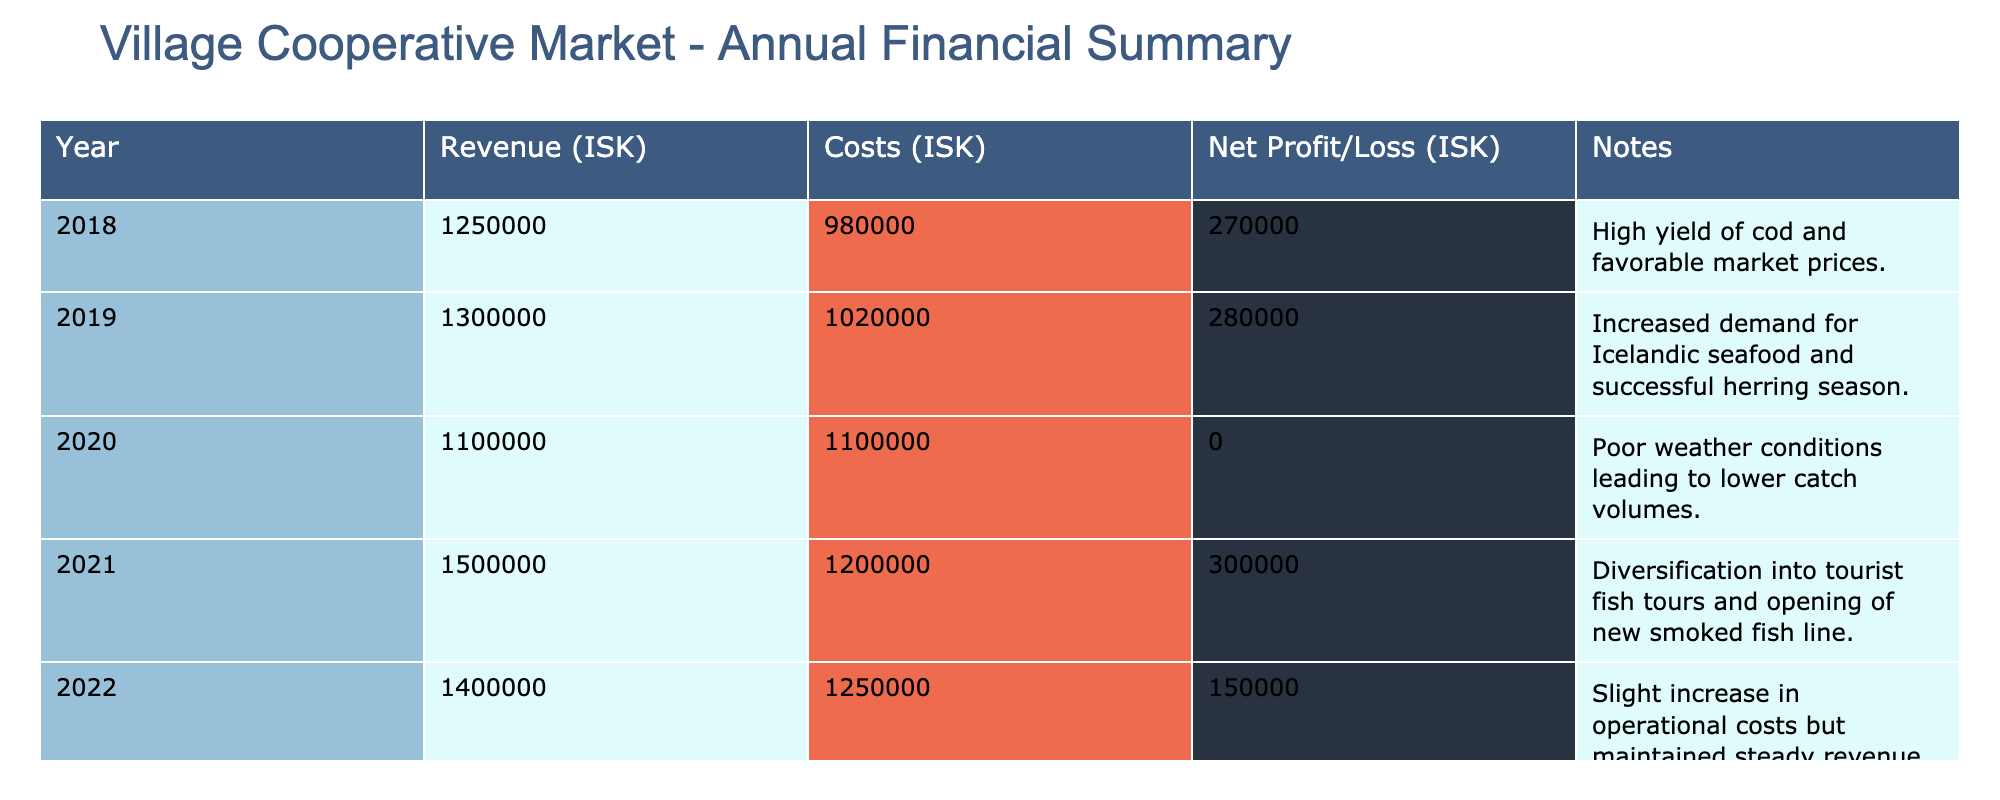What was the net profit in 2019? In 2019, the net profit recorded in the table is directly listed under the Net Profit/Loss column. It shows a value of 280,000 ISK.
Answer: 280000 Which year had the highest revenue? By examining the Revenue column, the year with the highest revenue is 2021 with a total of 1,500,000 ISK.
Answer: 2021 What is the total net profit from 2018 to 2022? To find the total net profit from 2018 to 2022, we sum the net profits for each year: 270,000 (2018) + 280,000 (2019) + 0 (2020) + 300,000 (2021) + 150,000 (2022) = 1,000,000 ISK.
Answer: 1000000 Did the costs ever exceed the revenue? By comparing the Costs and Revenue columns, we see that in 2020, the costs were equal to the revenue at 1,100,000 ISK. However, in 2020, they did not exceed it. Therefore, the statement is false.
Answer: No What was the average revenue over these five years? To calculate the average revenue, first sum the revenues: 1,250,000 (2018) + 1,300,000 (2019) + 1,100,000 (2020) + 1,500,000 (2021) + 1,400,000 (2022) = 6,550,000 ISK. Then divide by the 5 years, giving us an average of 1,310,000 ISK.
Answer: 1310000 Which year had the lowest net profit? The year with the lowest net profit can be found by referring to the Net Profit/Loss column. The value for 2020 is 0, which is lower than all other years' profits.
Answer: 2020 What was the increase in net profit from 2020 to 2021? To calculate the increase in net profit from 2020 to 2021, subtract the net profit of 2020 (0 ISK) from that of 2021 (300,000 ISK): 300,000 - 0 = 300,000 ISK.
Answer: 300000 Did the village cooperative market see a profit in 2020? The net profit for 2020 is recorded as 0 ISK, indicating that there was no profit in that year.
Answer: No 